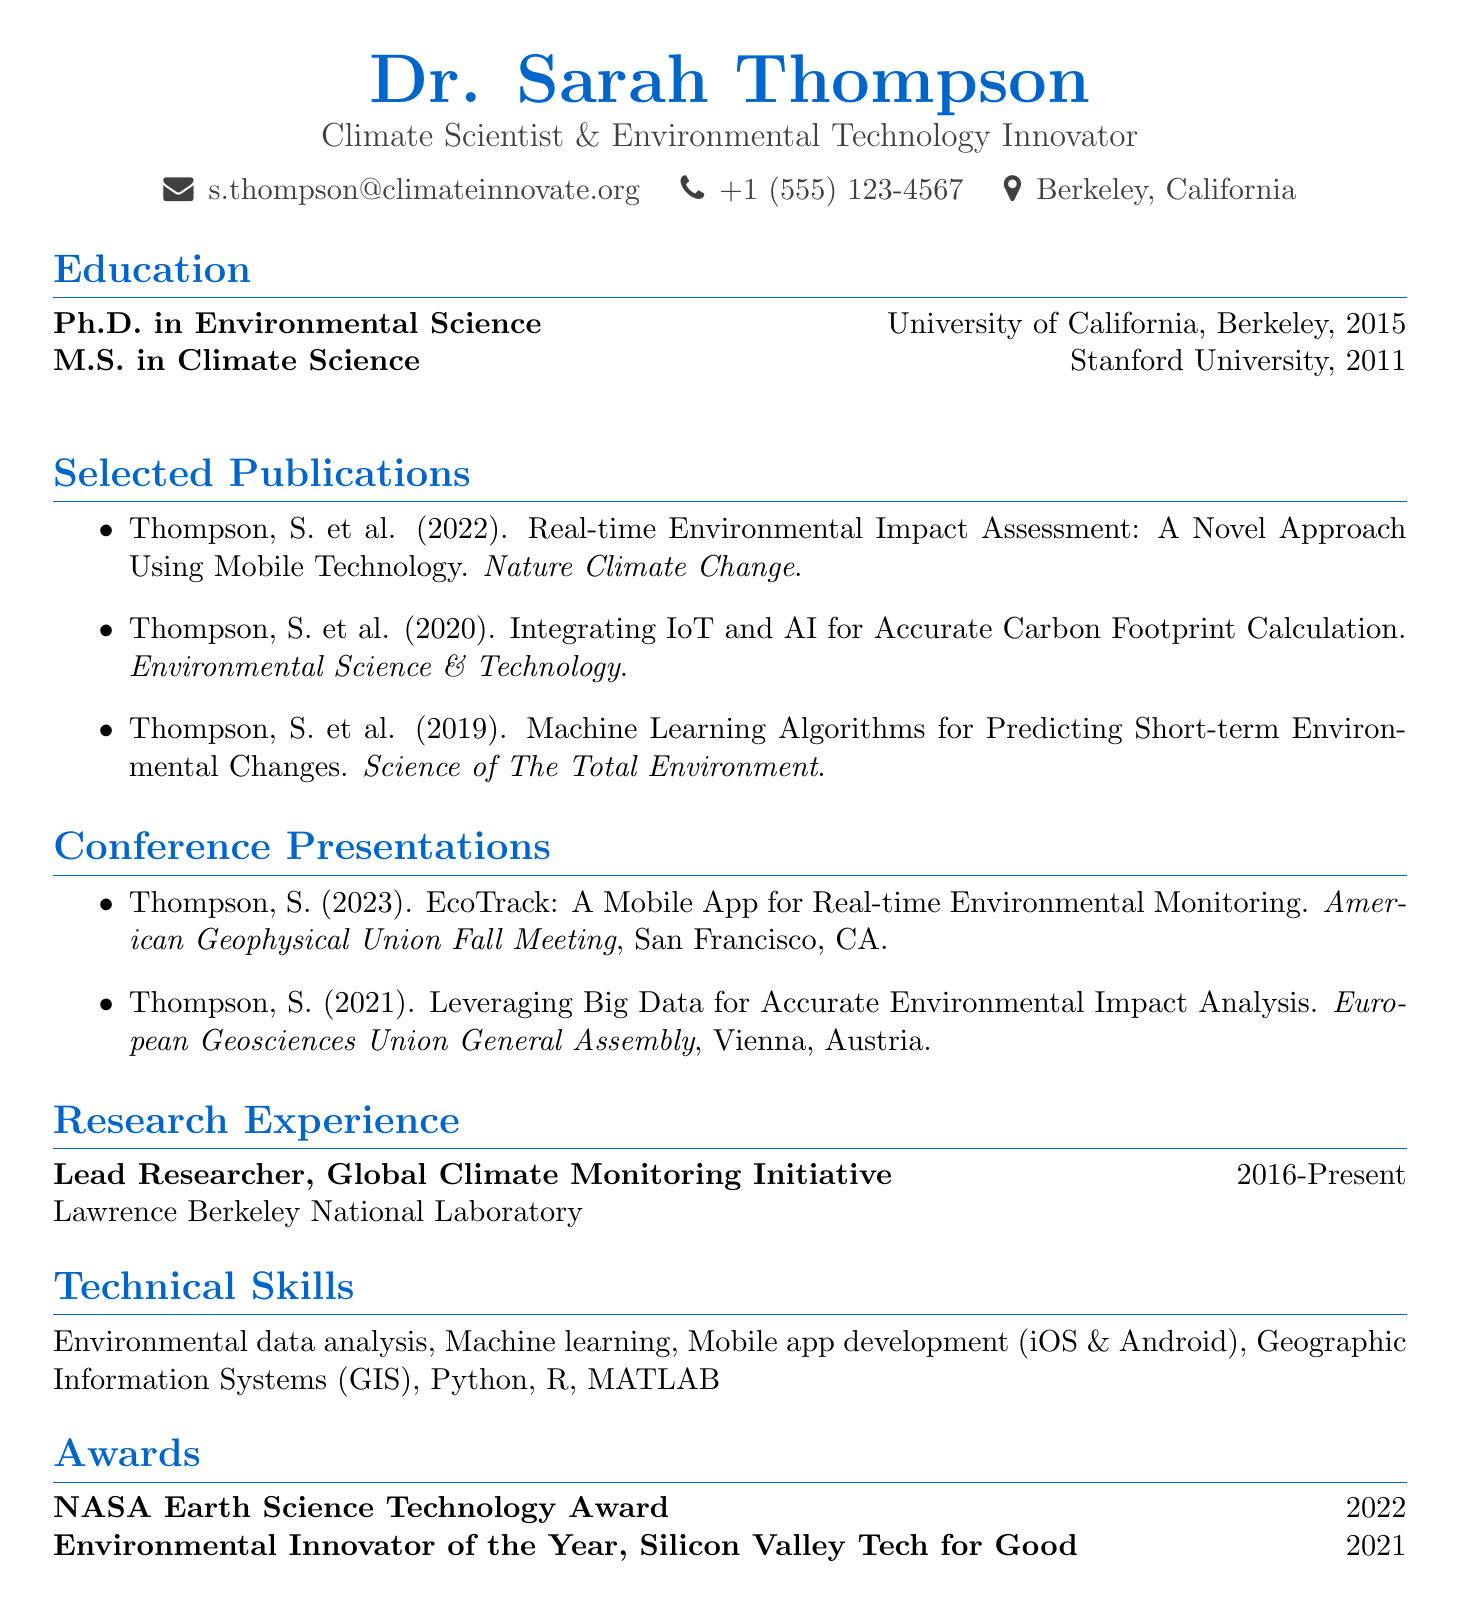What is the name of the individual? The name is provided in the personal information section of the document.
Answer: Dr. Sarah Thompson What year did Dr. Thompson obtain her Ph.D.? The education section lists the degrees and years obtained.
Answer: 2015 In which journal was the publication on mobile technology published? The document provides details about each publication, including the journal names.
Answer: Nature Climate Change What is the title of the presentation given in 2023? The conference presentations section lists the titles and years of the presentations.
Answer: EcoTrack: A Mobile App for Real-time Environmental Monitoring What award did Dr. Thompson receive in 2022? The awards section specifies the awards and years received.
Answer: NASA Earth Science Technology Award How long has Dr. Thompson been the Lead Researcher at Lawrence Berkeley National Laboratory? The research experience section provides the duration of the position held.
Answer: 2016-Present What conference did Dr. Thompson present at in Vienna? The document includes a list of conferences with their locations.
Answer: European Geosciences Union General Assembly Which skill is listed related to app development? The technical skills section lists specific skills.
Answer: Mobile app development (iOS & Android) How many publications are listed in the document? By counting the individual items in the selected publications section, the total can be determined.
Answer: Three 